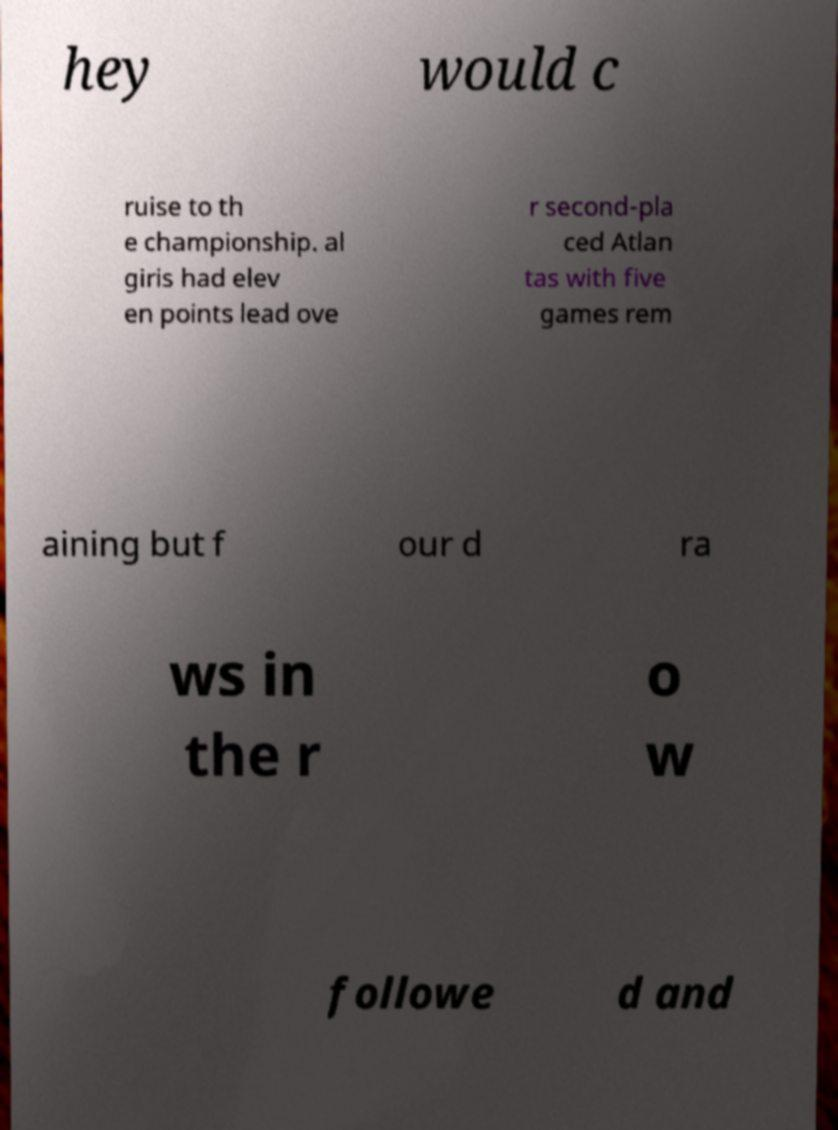Could you extract and type out the text from this image? hey would c ruise to th e championship. al giris had elev en points lead ove r second-pla ced Atlan tas with five games rem aining but f our d ra ws in the r o w followe d and 